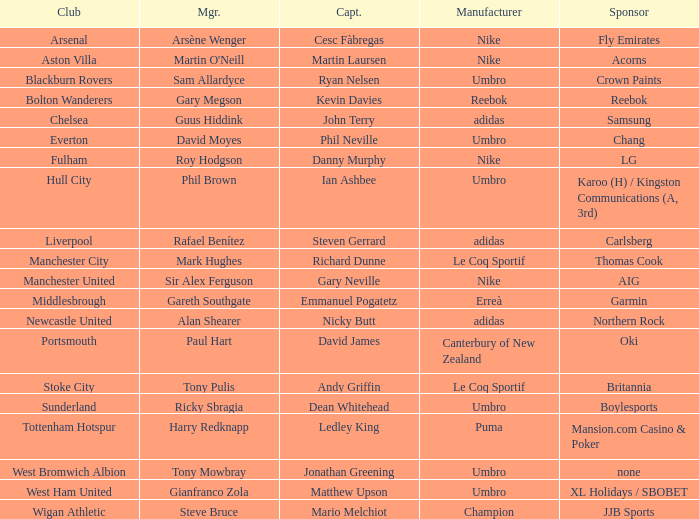Who is the captain of Middlesbrough? Emmanuel Pogatetz. 